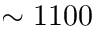Convert formula to latex. <formula><loc_0><loc_0><loc_500><loc_500>\sim 1 1 0 0</formula> 